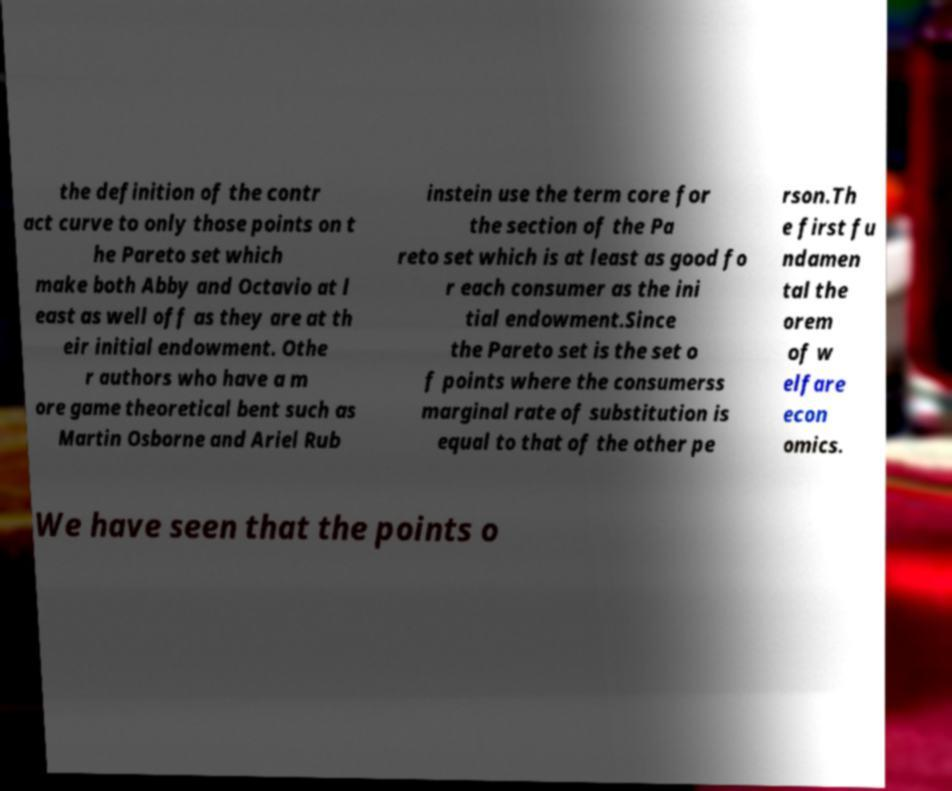Can you read and provide the text displayed in the image?This photo seems to have some interesting text. Can you extract and type it out for me? the definition of the contr act curve to only those points on t he Pareto set which make both Abby and Octavio at l east as well off as they are at th eir initial endowment. Othe r authors who have a m ore game theoretical bent such as Martin Osborne and Ariel Rub instein use the term core for the section of the Pa reto set which is at least as good fo r each consumer as the ini tial endowment.Since the Pareto set is the set o f points where the consumerss marginal rate of substitution is equal to that of the other pe rson.Th e first fu ndamen tal the orem of w elfare econ omics. We have seen that the points o 